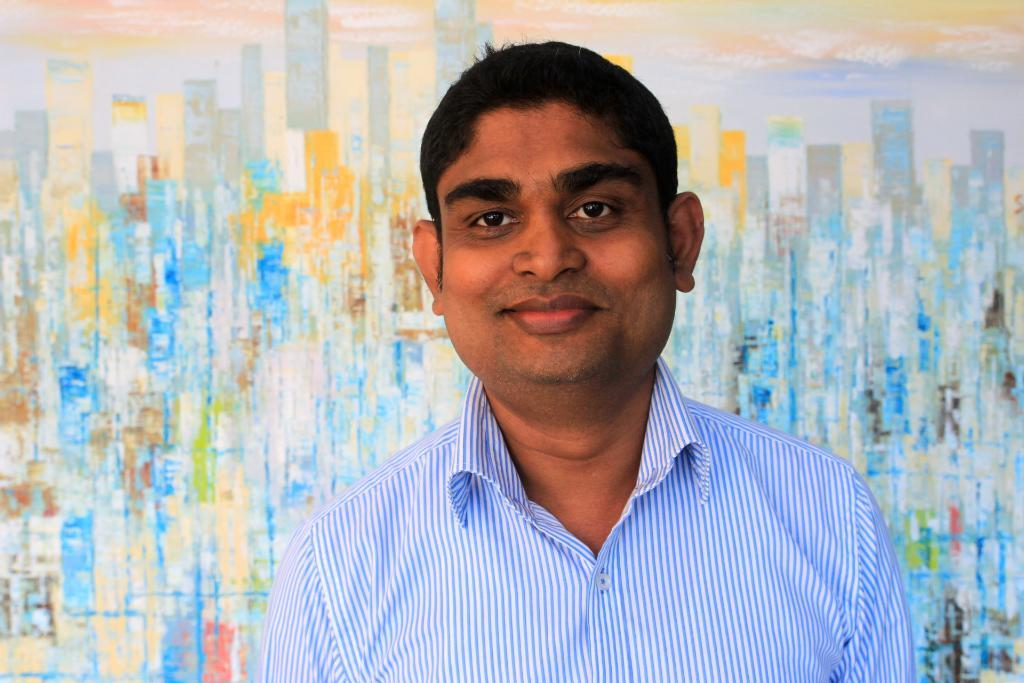Who is present in the image? There is a man in the image. What is the man's facial expression? The man is smiling. What can be seen in the background of the image? There is a wall with a painting on it in the background of the image. What type of sleet is falling in the image? There is no sleet present in the image; it is an indoor scene with a man and a wall with a painting. 